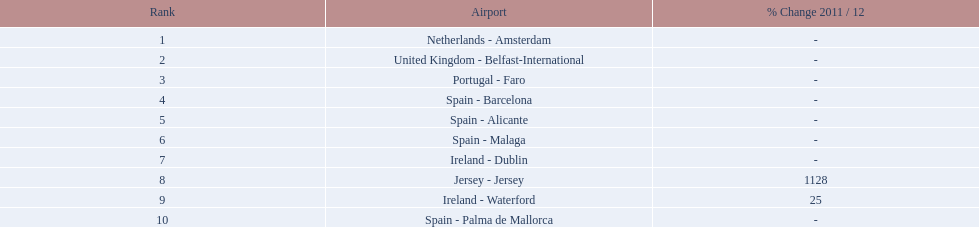Name all the london southend airports that did not list a change in 2001/12. Netherlands - Amsterdam, United Kingdom - Belfast-International, Portugal - Faro, Spain - Barcelona, Spain - Alicante, Spain - Malaga, Ireland - Dublin, Spain - Palma de Mallorca. What unchanged percentage airports from 2011/12 handled less then 50,000 passengers? Ireland - Dublin, Spain - Palma de Mallorca. What unchanged percentage airport from 2011/12 handled less then 50,000 passengers is the closest to the equator? Spain - Palma de Mallorca. 